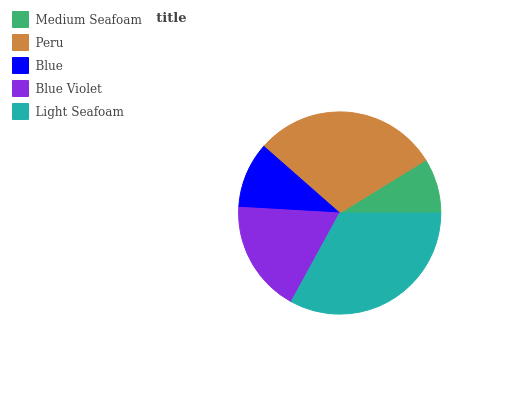Is Medium Seafoam the minimum?
Answer yes or no. Yes. Is Light Seafoam the maximum?
Answer yes or no. Yes. Is Peru the minimum?
Answer yes or no. No. Is Peru the maximum?
Answer yes or no. No. Is Peru greater than Medium Seafoam?
Answer yes or no. Yes. Is Medium Seafoam less than Peru?
Answer yes or no. Yes. Is Medium Seafoam greater than Peru?
Answer yes or no. No. Is Peru less than Medium Seafoam?
Answer yes or no. No. Is Blue Violet the high median?
Answer yes or no. Yes. Is Blue Violet the low median?
Answer yes or no. Yes. Is Light Seafoam the high median?
Answer yes or no. No. Is Medium Seafoam the low median?
Answer yes or no. No. 